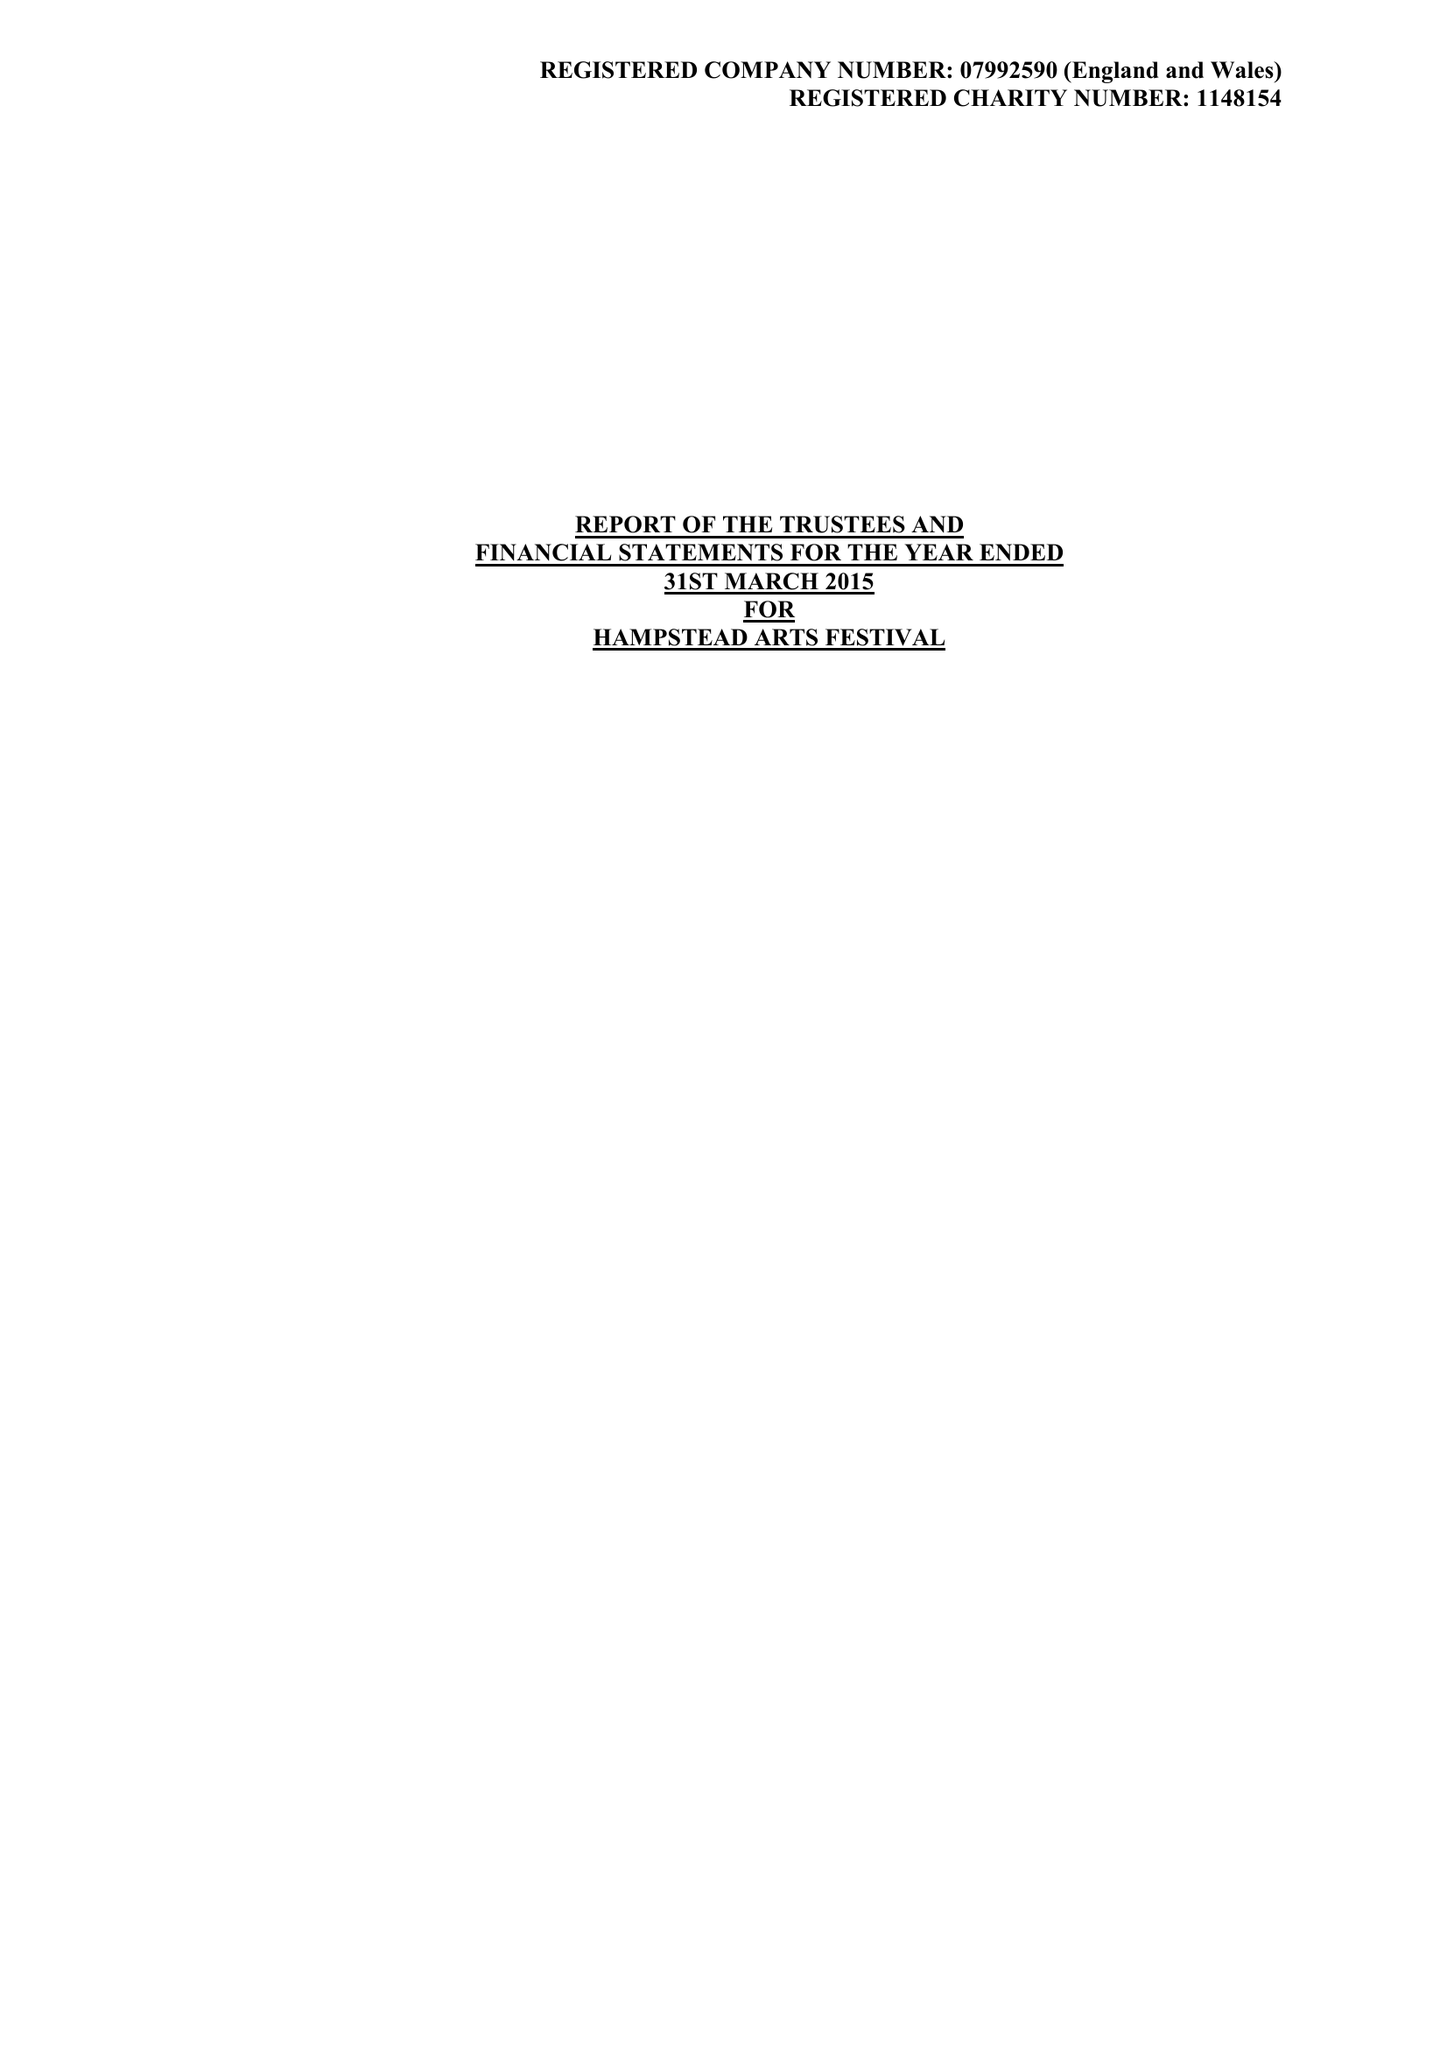What is the value for the charity_number?
Answer the question using a single word or phrase. 1148154 